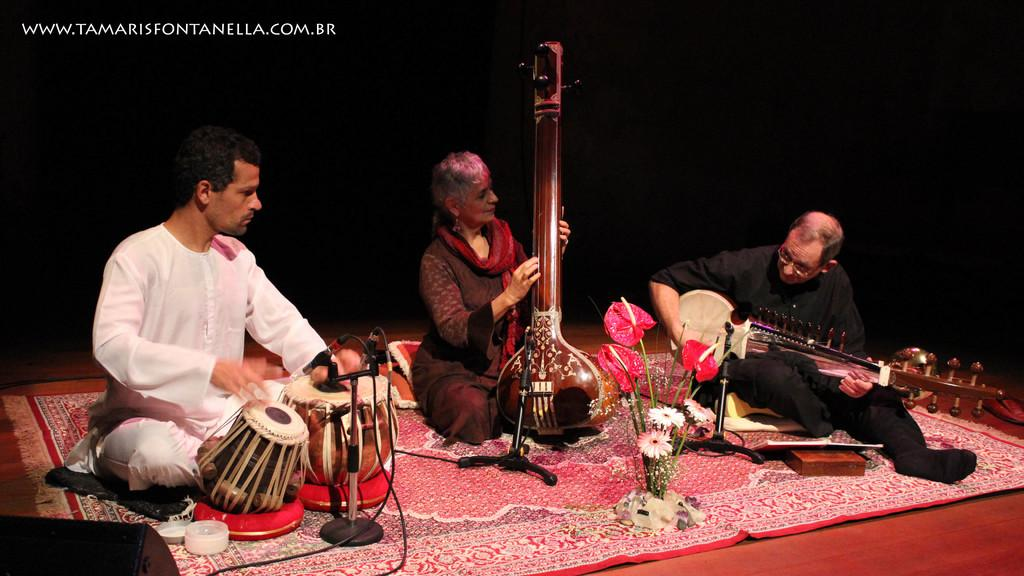How many people are in the image? There are three persons in the image. What are the persons doing in the image? They are sitting on a carpet and playing musical instruments. Can you identify any specific instruments in the image? Yes, one of the instruments is a tabla, and another is a sitar. What is the color of the background in the image? The background of the image is dark. Is there any additional mark or feature on the image? Yes, there is a watermark on the image. How do the persons maintain their balance while playing the instruments in the image? The persons are sitting on a carpet, so they do not need to maintain their balance while playing the instruments. Can you see any evidence of flight in the image? No, there is no evidence of flight in the image. 